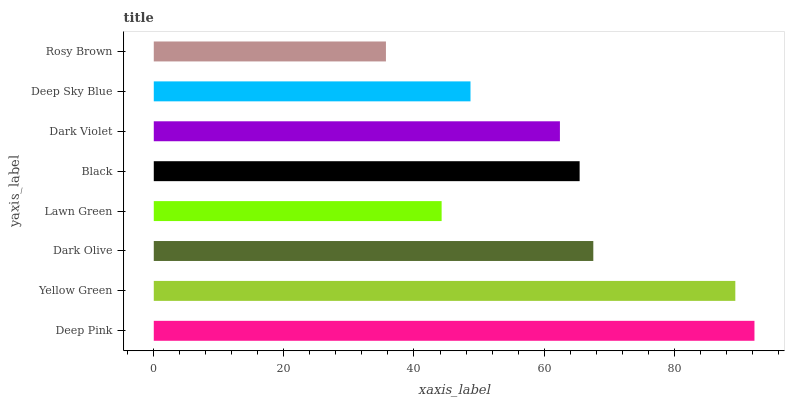Is Rosy Brown the minimum?
Answer yes or no. Yes. Is Deep Pink the maximum?
Answer yes or no. Yes. Is Yellow Green the minimum?
Answer yes or no. No. Is Yellow Green the maximum?
Answer yes or no. No. Is Deep Pink greater than Yellow Green?
Answer yes or no. Yes. Is Yellow Green less than Deep Pink?
Answer yes or no. Yes. Is Yellow Green greater than Deep Pink?
Answer yes or no. No. Is Deep Pink less than Yellow Green?
Answer yes or no. No. Is Black the high median?
Answer yes or no. Yes. Is Dark Violet the low median?
Answer yes or no. Yes. Is Lawn Green the high median?
Answer yes or no. No. Is Rosy Brown the low median?
Answer yes or no. No. 